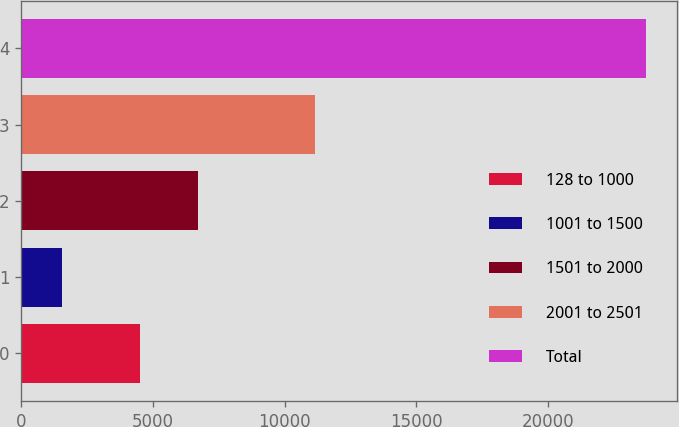<chart> <loc_0><loc_0><loc_500><loc_500><bar_chart><fcel>128 to 1000<fcel>1001 to 1500<fcel>1501 to 2000<fcel>2001 to 2501<fcel>Total<nl><fcel>4495<fcel>1551<fcel>6712.1<fcel>11133<fcel>23722<nl></chart> 